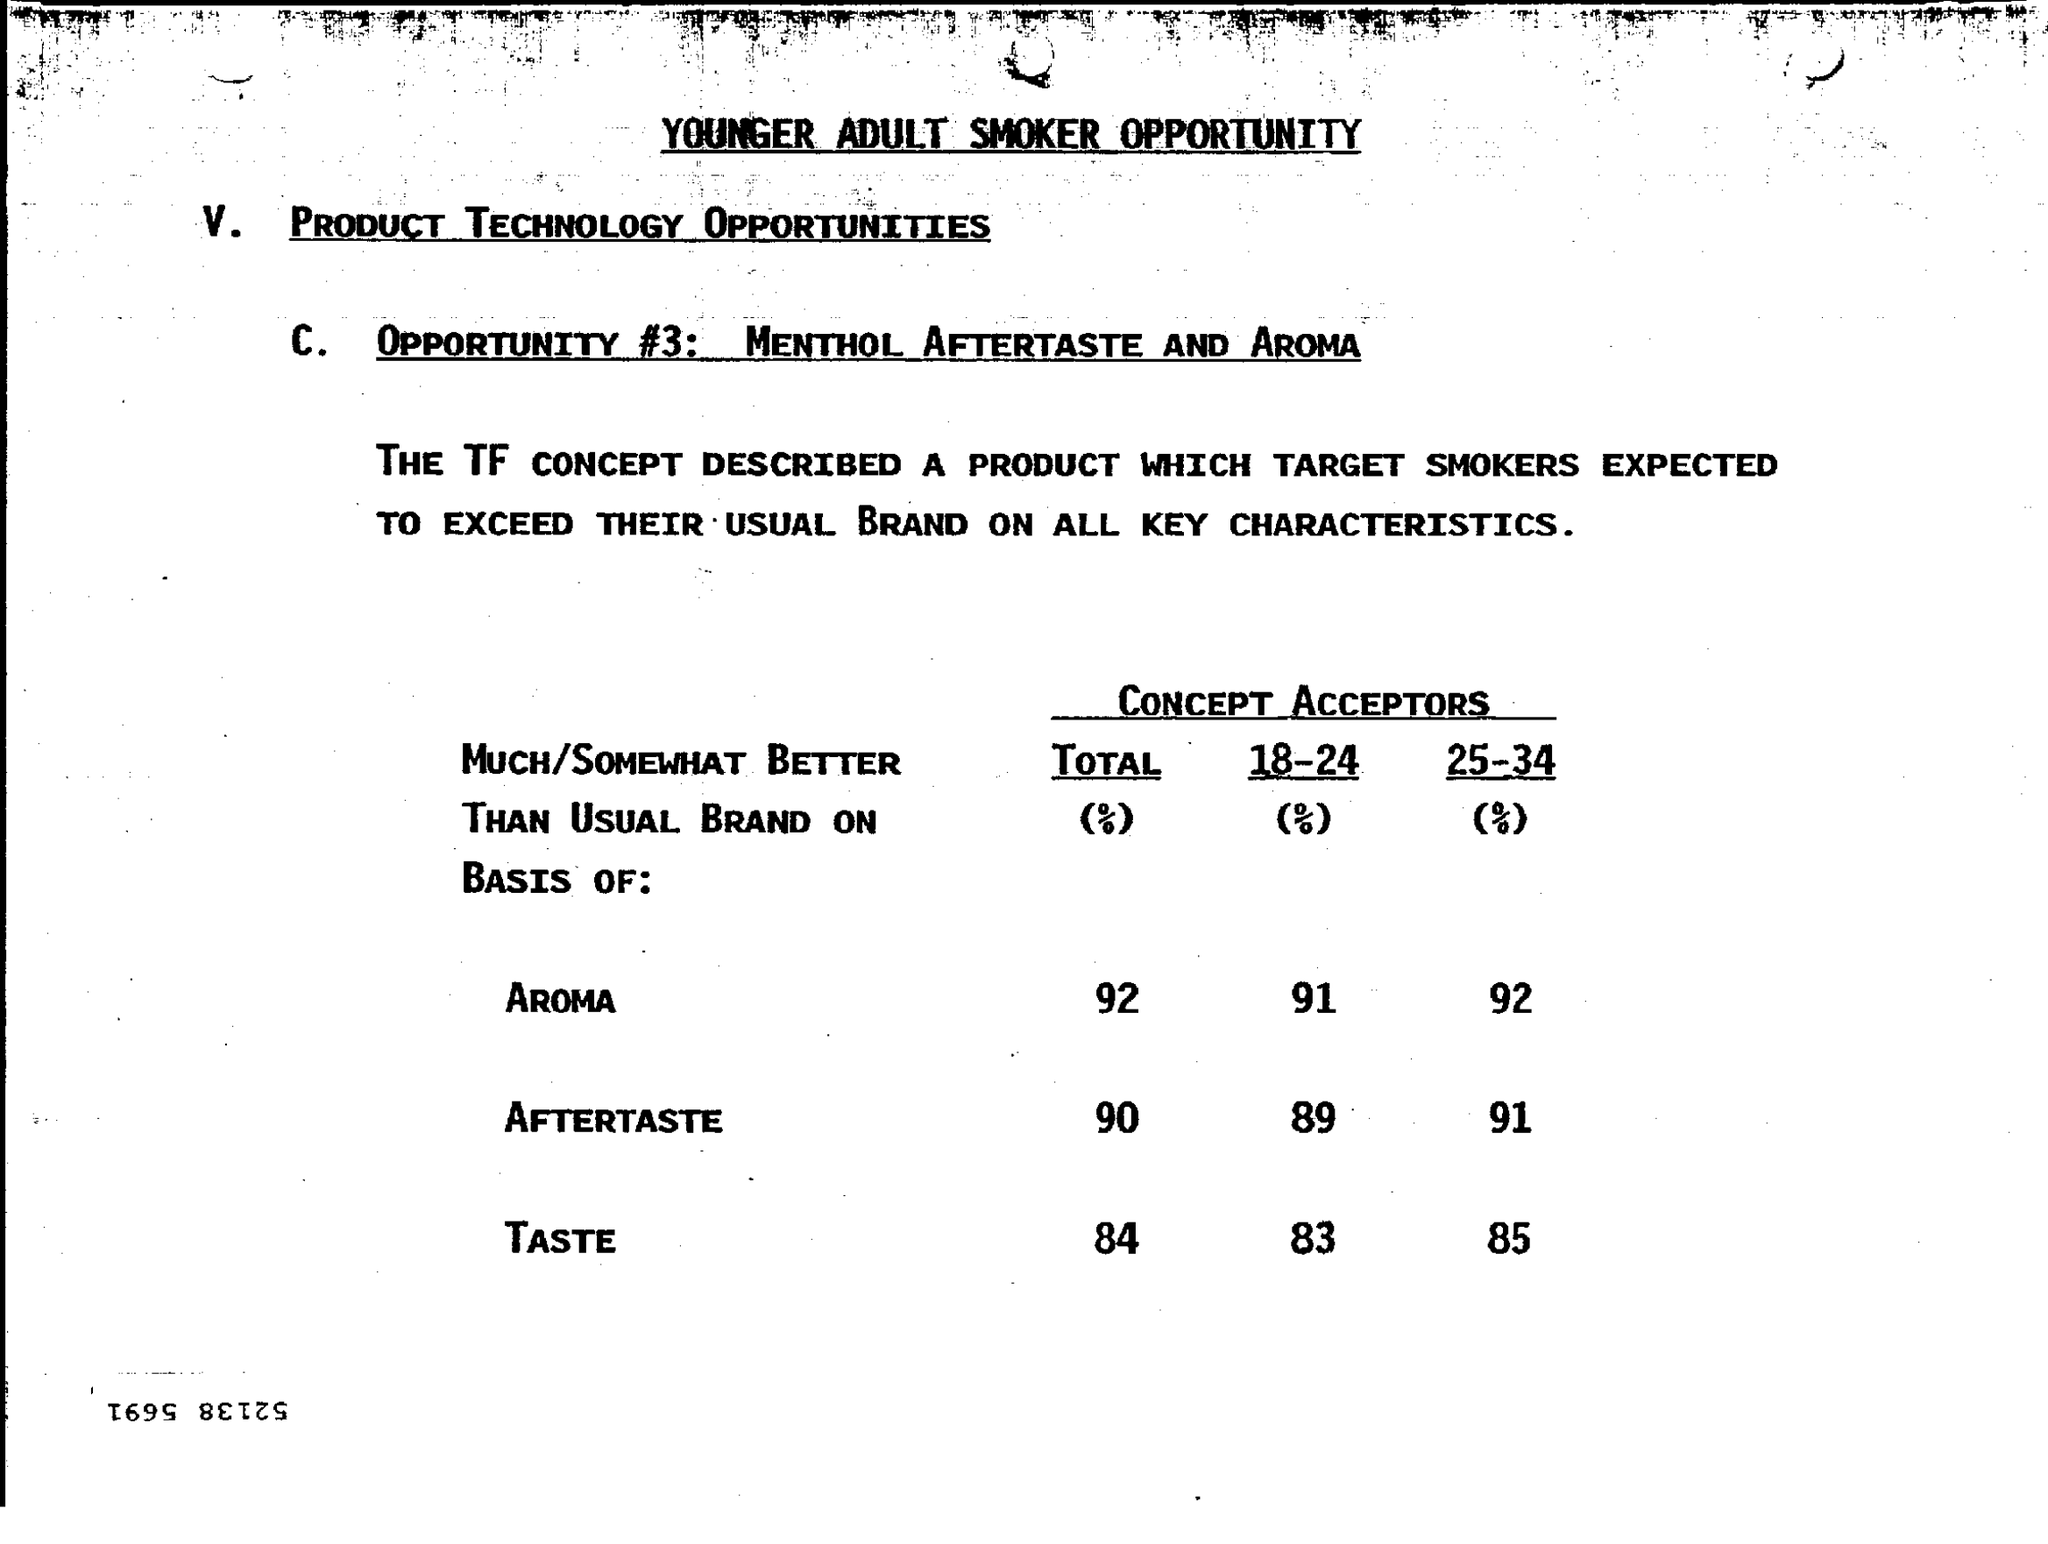What is the total % of aroma ?
Keep it short and to the point. 92. What is the total % of after taste ?
Provide a short and direct response. 90. What is the total % taste ?
Offer a very short reply. 84. What is the aroma for 18-24% ?
Give a very brief answer. 91. What is  the aroma for 25-34% ?
Provide a succinct answer. 92. 